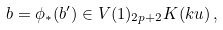Convert formula to latex. <formula><loc_0><loc_0><loc_500><loc_500>b = \phi _ { * } ( b ^ { \prime } ) \in V ( 1 ) _ { 2 p + 2 } K ( k u ) \, ,</formula> 